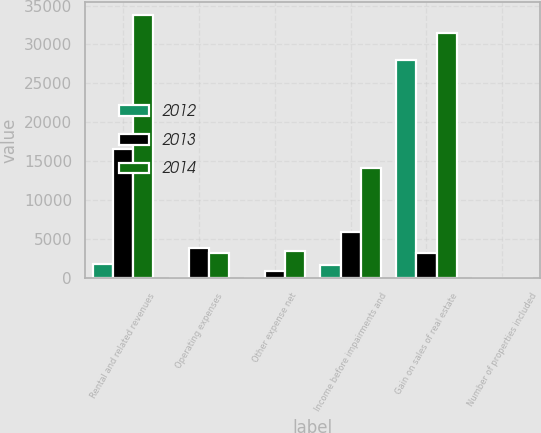<chart> <loc_0><loc_0><loc_500><loc_500><stacked_bar_chart><ecel><fcel>Rental and related revenues<fcel>Operating expenses<fcel>Other expense net<fcel>Income before impairments and<fcel>Gain on sales of real estate<fcel>Number of properties included<nl><fcel>2012<fcel>1810<fcel>54<fcel>20<fcel>1736<fcel>28010<fcel>3<nl><fcel>2013<fcel>16649<fcel>3929<fcel>979<fcel>5879<fcel>3304<fcel>16<nl><fcel>2014<fcel>33777<fcel>3304<fcel>3467<fcel>14198<fcel>31454<fcel>20<nl></chart> 